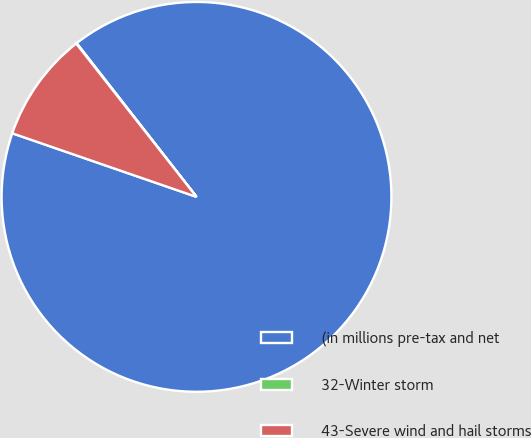Convert chart. <chart><loc_0><loc_0><loc_500><loc_500><pie_chart><fcel>(in millions pre-tax and net<fcel>32-Winter storm<fcel>43-Severe wind and hail storms<nl><fcel>90.83%<fcel>0.05%<fcel>9.12%<nl></chart> 